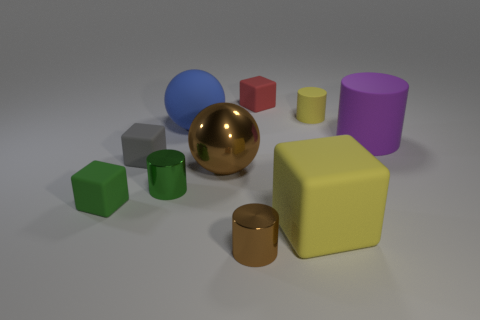Is there any pattern or theme to the arrangement of these objects? While there does not appear to be an explicit pattern or theme in their arrangement, the objects are neatly spaced, which may suggest a deliberate organization, perhaps to showcase the variety of shapes and colors or to create a visually balanced composition. Does the lighting in the image reveal anything about the texture of the objects? Yes, the lighting plays a significant role in highlighting the textures of the objects. The sheen on the brown cylinder and large sphere indicates they are reflective and likely metallic, while the matte finish on the blue sphere and purple cylinder suggests they have a more diffuse surface that doesn't reflect light as directly. 